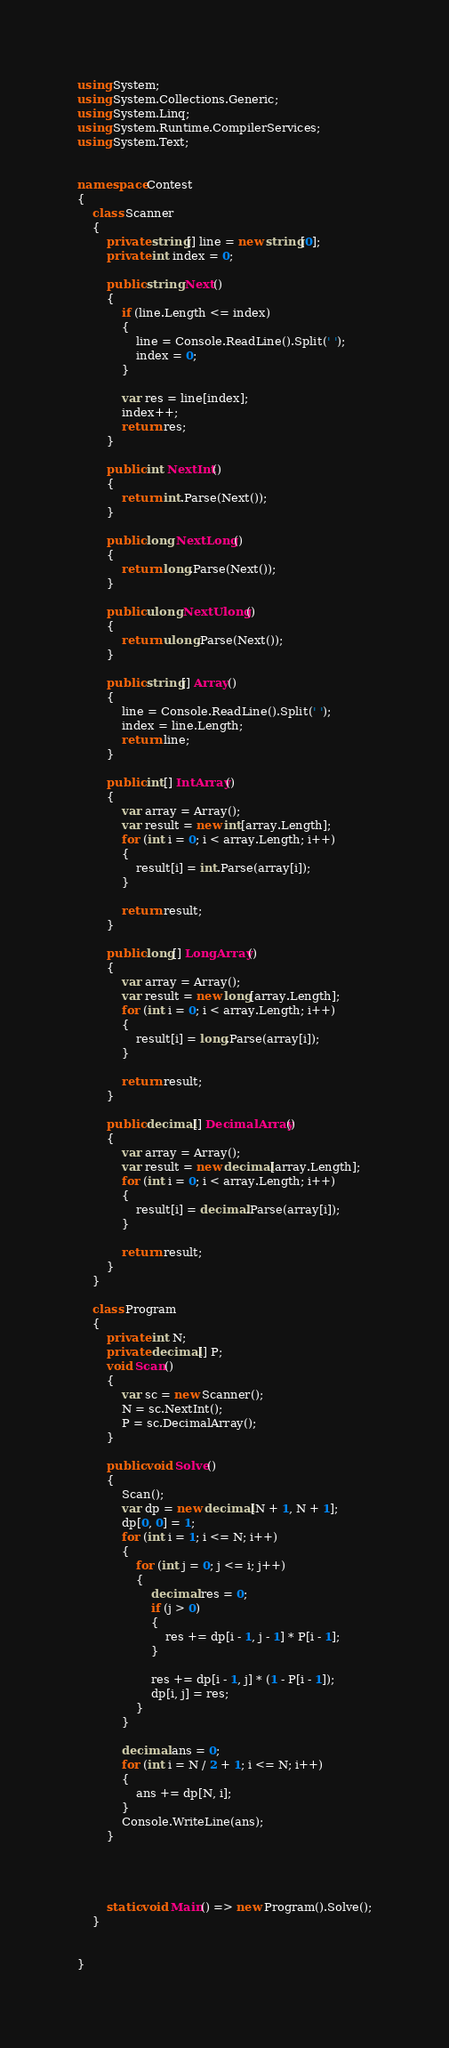Convert code to text. <code><loc_0><loc_0><loc_500><loc_500><_C#_>using System;
using System.Collections.Generic;
using System.Linq;
using System.Runtime.CompilerServices;
using System.Text;


namespace Contest
{
    class Scanner
    {
        private string[] line = new string[0];
        private int index = 0;

        public string Next()
        {
            if (line.Length <= index)
            {
                line = Console.ReadLine().Split(' ');
                index = 0;
            }

            var res = line[index];
            index++;
            return res;
        }

        public int NextInt()
        {
            return int.Parse(Next());
        }

        public long NextLong()
        {
            return long.Parse(Next());
        }

        public ulong NextUlong()
        {
            return ulong.Parse(Next());
        }

        public string[] Array()
        {
            line = Console.ReadLine().Split(' ');
            index = line.Length;
            return line;
        }

        public int[] IntArray()
        {
            var array = Array();
            var result = new int[array.Length];
            for (int i = 0; i < array.Length; i++)
            {
                result[i] = int.Parse(array[i]);
            }

            return result;
        }

        public long[] LongArray()
        {
            var array = Array();
            var result = new long[array.Length];
            for (int i = 0; i < array.Length; i++)
            {
                result[i] = long.Parse(array[i]);
            }

            return result;
        }

        public decimal[] DecimalArray()
        {
            var array = Array();
            var result = new decimal[array.Length];
            for (int i = 0; i < array.Length; i++)
            {
                result[i] = decimal.Parse(array[i]);
            }

            return result;
        }
    }

    class Program
    {
        private int N;
        private decimal[] P;
        void Scan()
        {
            var sc = new Scanner();
            N = sc.NextInt();
            P = sc.DecimalArray();
        }

        public void Solve()
        {
            Scan();
            var dp = new decimal[N + 1, N + 1];
            dp[0, 0] = 1;
            for (int i = 1; i <= N; i++)
            {
                for (int j = 0; j <= i; j++)
                {
                    decimal res = 0;
                    if (j > 0)
                    {
                        res += dp[i - 1, j - 1] * P[i - 1];
                    }

                    res += dp[i - 1, j] * (1 - P[i - 1]);
                    dp[i, j] = res;
                }
            }

            decimal ans = 0;
            for (int i = N / 2 + 1; i <= N; i++)
            {
                ans += dp[N, i];
            }
            Console.WriteLine(ans);
        }




        static void Main() => new Program().Solve();
    }


}</code> 